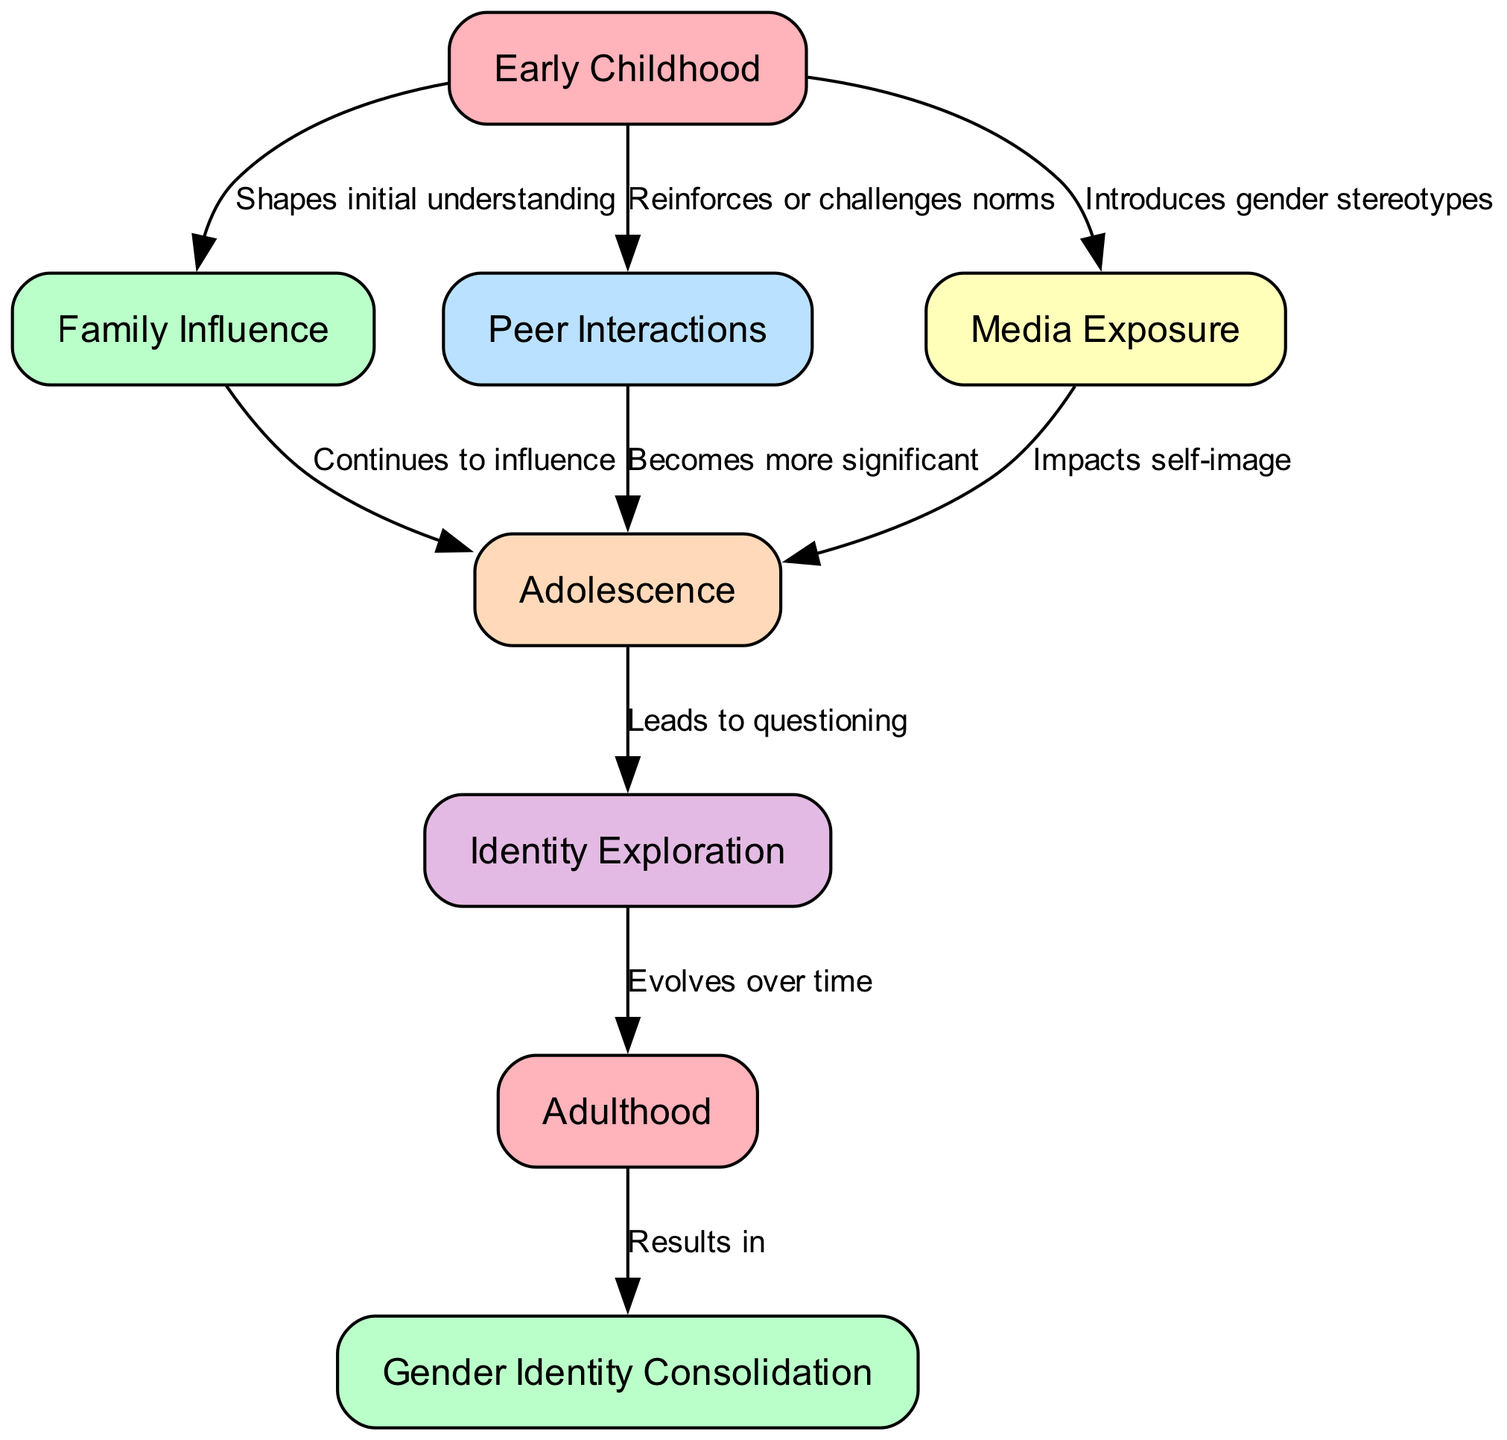What is the first node in the flow chart? The first node in the flow chart is "Early Childhood," which is visually the starting point of the diagram.
Answer: Early Childhood How many nodes are present in the diagram? By counting all the unique entries labeled in the nodes section of the data, we find there are eight distinct nodes in total.
Answer: 8 What is the connection between "Early Childhood" and "Family Influence"? The edge between these two nodes indicates that "Early Childhood" shapes initial understanding, establishing a foundational relationship in the diagram.
Answer: Shapes initial understanding Which nodes have an outgoing connection to "Adolescence"? The nodes "Family Influence," "Peer Interactions," and "Media Exposure" all have directed edges leading to "Adolescence," indicating multiple influences feeding into this stage.
Answer: Family Influence, Peer Interactions, Media Exposure What follows after "Identity Exploration"? The diagram shows that "Identity Exploration" leads to "Adulthood," highlighting a developmental progression from exploring identity to becoming an adult.
Answer: Adulthood What does "Adulthood" lead to in the flow chart? "Adulthood" directly leads to "Gender Identity Consolidation," illustrating that experiences in adulthood culminate in a settled understanding of gender identity.
Answer: Gender Identity Consolidation How does "Media Exposure" impact "Adolescence"? The diagram states that "Media Exposure" impacts self-image during "Adolescence," indicating that media plays a critical role in shaping adolescent self-perception.
Answer: Impacts self-image What is the main purpose of the flow chart? The overall purpose of the flow chart is to outline the stages of gender identity formation and the various influences at each stage.
Answer: To outline gender identity formation stages 